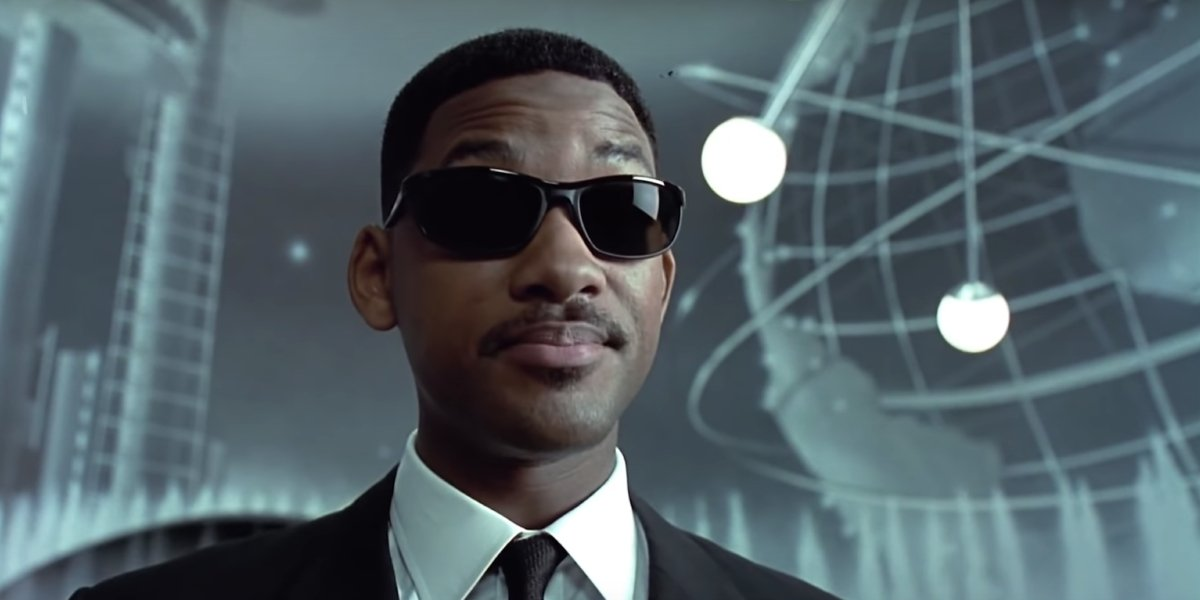What can you tell me about the character in this image? The character in the image is a secret agent exuding confidence and mystery. Clad in a sleek black suit, white shirt, and black tie, his look is completed with iconic black sunglasses. The futuristic background with a large metallic globe and scientific equipment hints at his involvement in high-tech, perhaps extraterrestrial missions. His serious expression and direct gaze imply a focused and determined personality, fitting for someone who likely handles critical and secretive operations. What kind of science-fiction technology could this character be associated with? Given the sophisticated and futuristic backdrop, the character may be associated with cutting-edge technology such as teleportation devices, neuralyzer gadgets for memory erasure, advanced weaponry, and intergalactic communication systems. These tech elements align with the secretive and high-stakes nature of his missions, ensuring he's well-equipped to handle any extraterrestrial or high-tech threats. Imagine a scenario where this character encounters an alien race for the first time. What happens? In a high-stakes encounter, the secret agent finds himself face-to-face with Thraxiols, an alien race known for their advanced intelligence and cryptic behavior. As he steps into their illuminated spaceship, the air thrums with a strange energy. His neuralyzer is ready, but he's cautious. Thraxiols communicate through complex light patterns and the agent quickly decodes their language. A tense negotiation begins, with each side wary of the other's intentions. The agent showcases advanced tech to win their trust, and an unlikely alliance starts to form, altering the course of human-alien relations forever. 